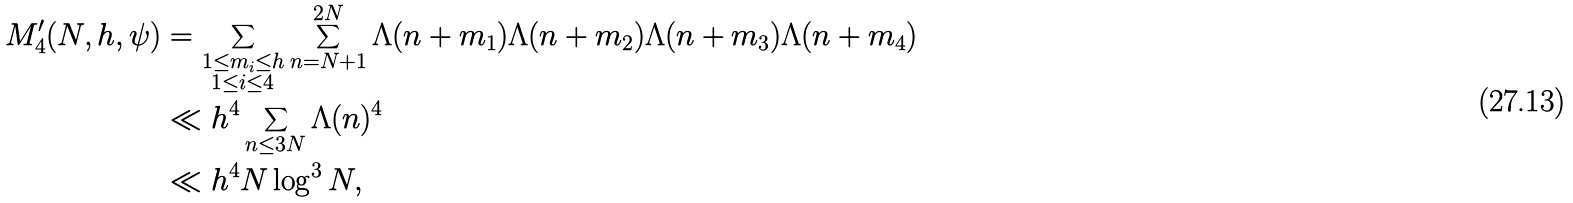<formula> <loc_0><loc_0><loc_500><loc_500>M _ { 4 } ^ { \prime } ( N , h , \psi ) & = \sum _ { \substack { 1 \leq m _ { i } \leq h \\ 1 \leq i \leq 4 } } \sum _ { n = N + 1 } ^ { 2 N } \Lambda ( n + m _ { 1 } ) \Lambda ( n + m _ { 2 } ) \Lambda ( n + m _ { 3 } ) \Lambda ( n + m _ { 4 } ) \\ & \ll h ^ { 4 } \sum _ { n \leq 3 N } \Lambda ( n ) ^ { 4 } \\ & \ll h ^ { 4 } N \log ^ { 3 } N ,</formula> 